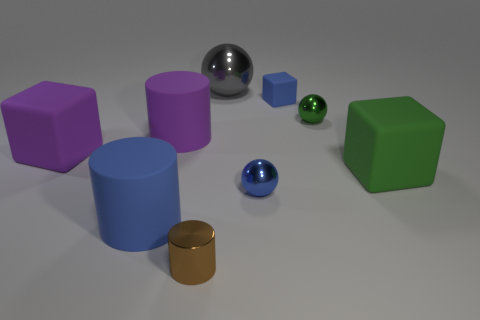What is the material of the blue thing that is the same shape as the gray object?
Offer a terse response. Metal. There is a shiny sphere that is to the left of the tiny blue matte object and in front of the tiny matte object; what color is it?
Offer a terse response. Blue. The big shiny ball is what color?
Keep it short and to the point. Gray. There is a tiny object that is the same color as the small cube; what is its material?
Give a very brief answer. Metal. Is there another matte thing that has the same shape as the small matte object?
Make the answer very short. Yes. There is a metal ball in front of the big green block; what size is it?
Provide a succinct answer. Small. What is the material of the blue thing that is the same size as the gray metallic object?
Provide a succinct answer. Rubber. Is the number of tiny blocks greater than the number of tiny purple rubber cylinders?
Give a very brief answer. Yes. How big is the blue matte thing behind the tiny blue object that is in front of the large green matte object?
Your answer should be very brief. Small. The blue shiny thing that is the same size as the blue cube is what shape?
Provide a succinct answer. Sphere. 